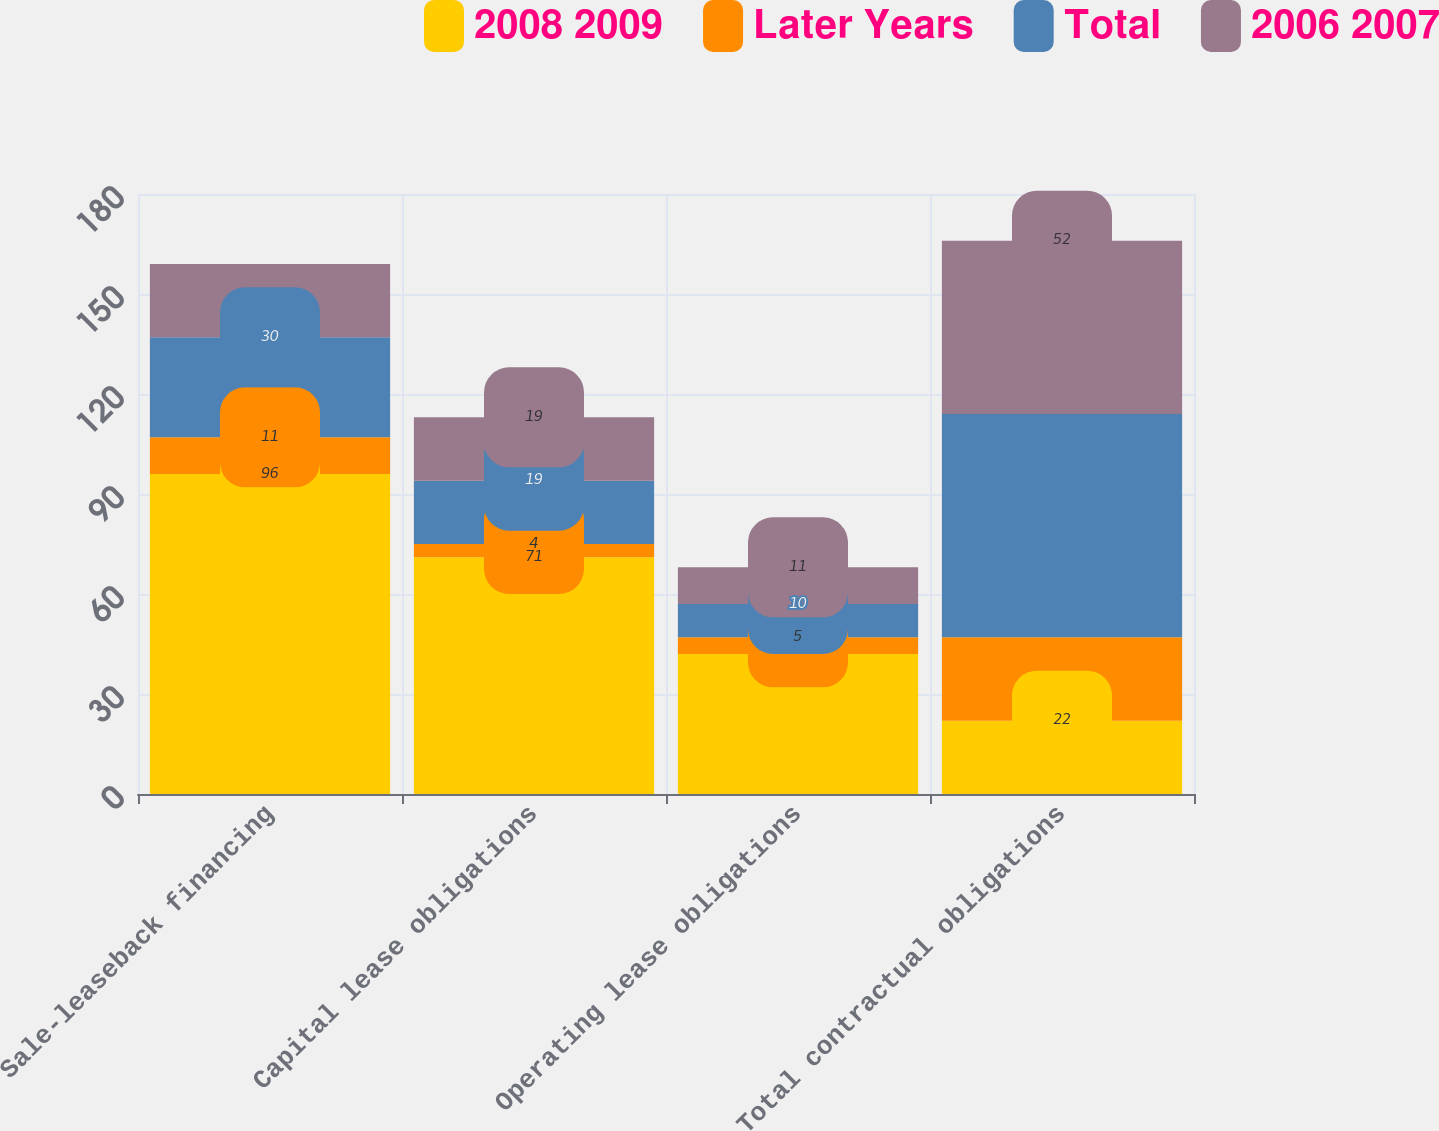<chart> <loc_0><loc_0><loc_500><loc_500><stacked_bar_chart><ecel><fcel>Sale-leaseback financing<fcel>Capital lease obligations<fcel>Operating lease obligations<fcel>Total contractual obligations<nl><fcel>2008 2009<fcel>96<fcel>71<fcel>42<fcel>22<nl><fcel>Later Years<fcel>11<fcel>4<fcel>5<fcel>25<nl><fcel>Total<fcel>30<fcel>19<fcel>10<fcel>67<nl><fcel>2006 2007<fcel>22<fcel>19<fcel>11<fcel>52<nl></chart> 